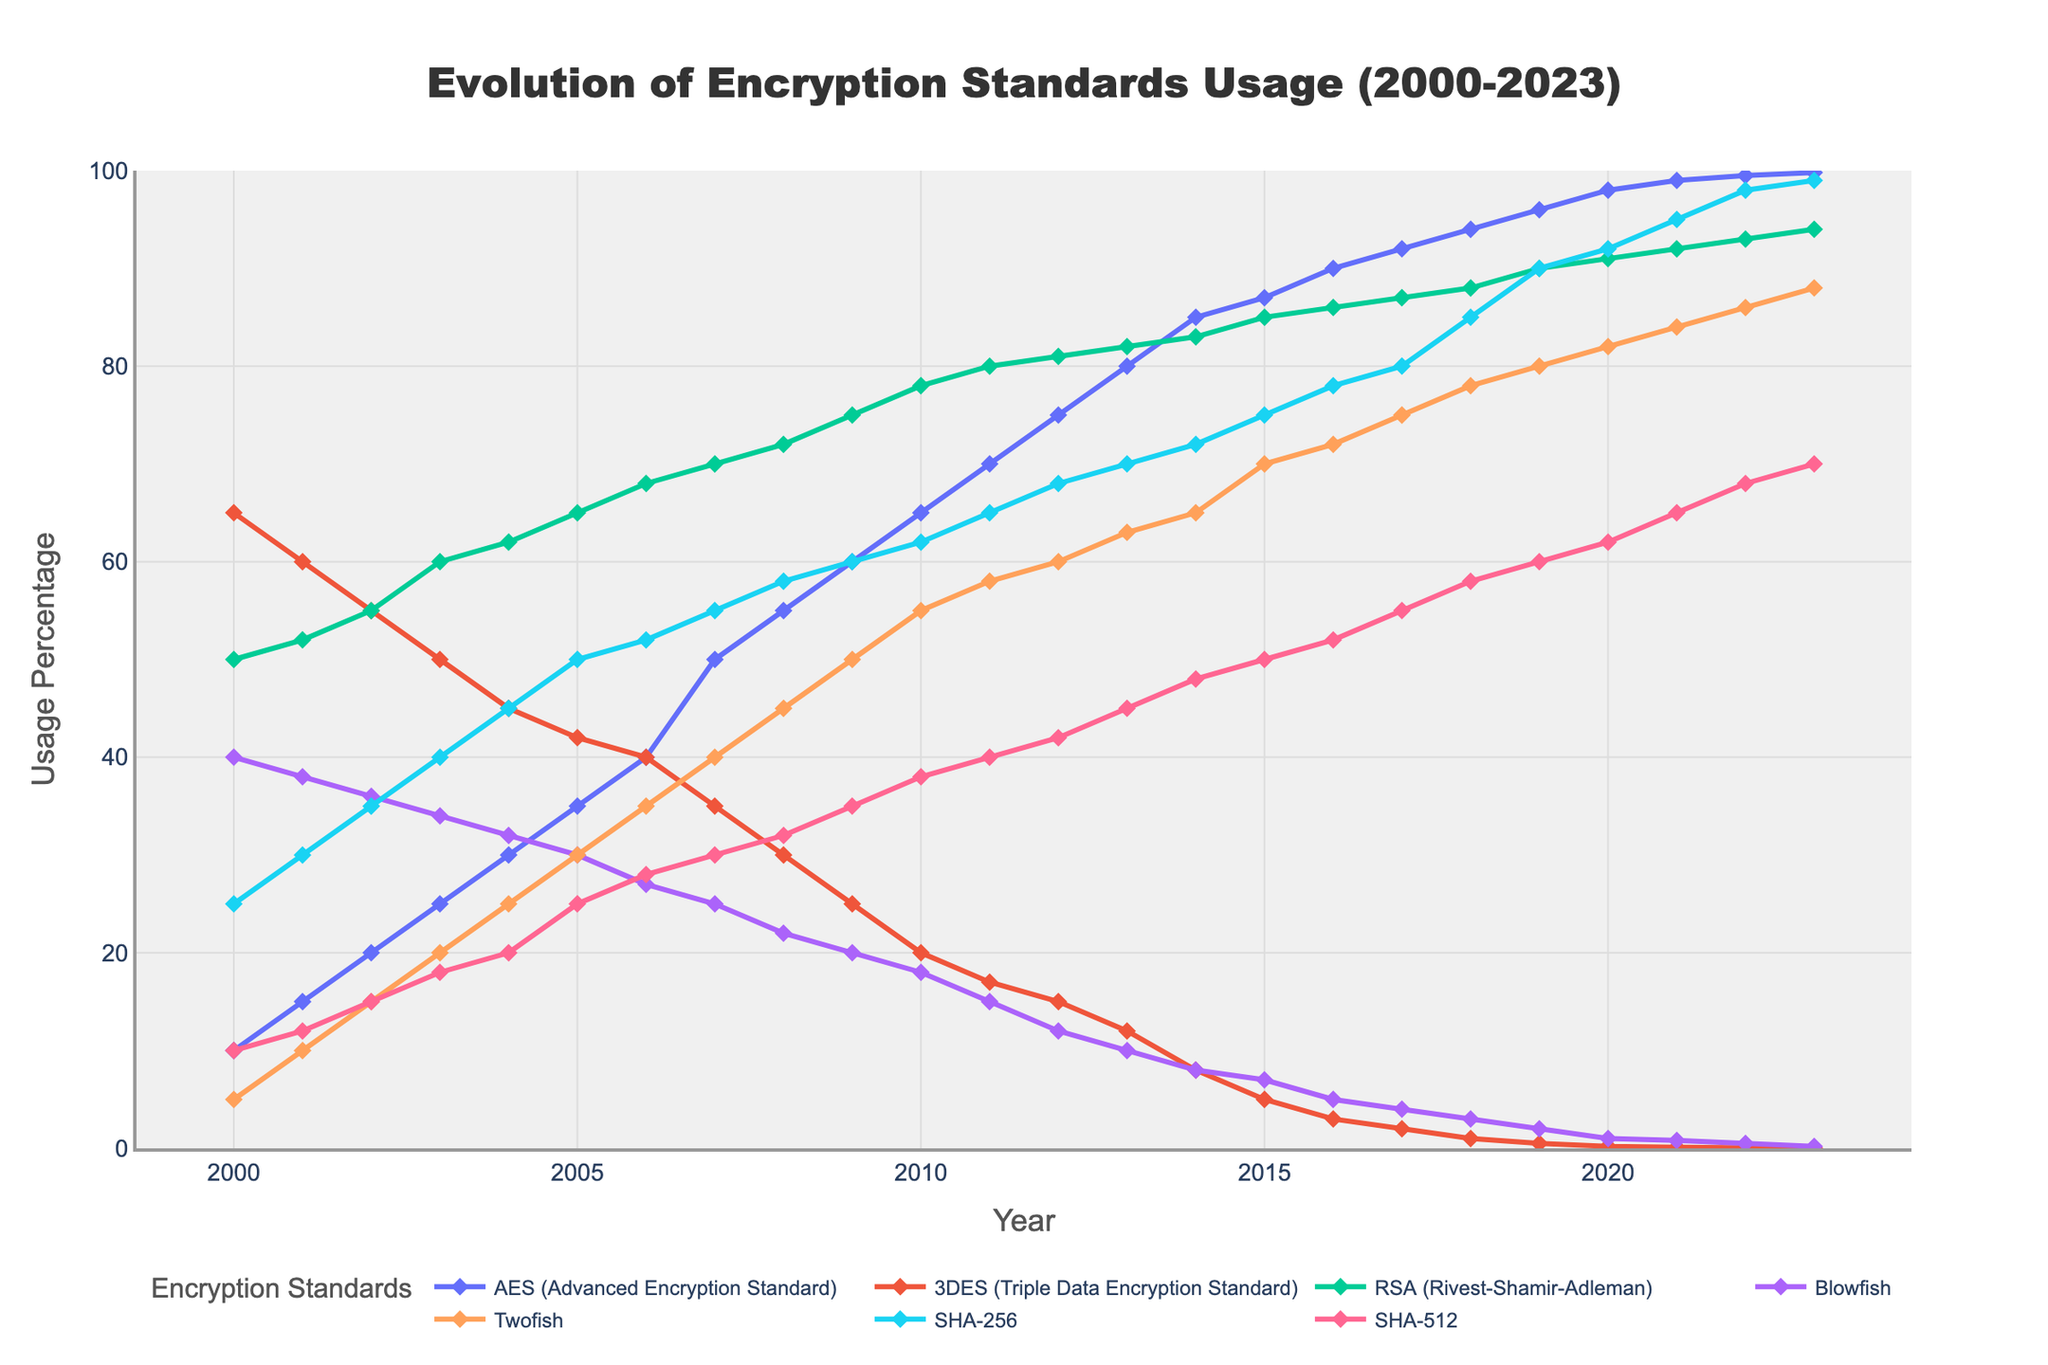What is the title of the figure? The title of the figure is located at the top and clearly indicates the subject of the plot. It reads "Evolution of Encryption Standards Usage (2000-2023)."
Answer: Evolution of Encryption Standards Usage (2000-2023) Which encryption standard had consistently decreasing usage from 2008 to 2023? To answer this, observe the lines on the plot. The line representing 3DES (Triple Data Encryption Standard) shows a consistent downward trend from 2008 to 2023.
Answer: 3DES (Triple Data Encryption Standard) In which year did AES (Advanced Encryption Standard) first surpass 50% usage? Locate the line for AES and check where it crosses the 50% usage mark on the y-axis. This occurs around the year 2007.
Answer: 2007 What was the usage percentage of RSA (Rivest-Shamir-Adleman) in the year 2010? Find the line representing RSA and trace it to the point corresponding to the year 2010. The y-value indicates the usage percentage, which is 78%.
Answer: 78% Compare the usage trends of Blowfish and Twofish from 2000 to 2023. Which had a higher initial usage and how do their trends differ? Both lines start close in 2000, but Blowfish starts higher at 40% compared to Twofish at 5%. Blowfish shows a consistent decline, while Twofish gradually increases until both lines are at a relatively low usage by 2023.
Answer: Blowfish had a higher initial usage; Blowfish declined, Twofish increased then stabilized How many encryption standards reached over 90% usage by 2023? Look at the lines and see which ones cross the 90% mark on the y-axis by 2023. Only AES and SHA-256 reach over 90% usage by 2023.
Answer: 2 encryption standards (AES and SHA-256) What is the difference in usage percentage between AES and 3DES in the year 2022? Find the usage percentages of AES and 3DES in 2022. AES is at 99.5% and 3DES is at 0.05%. Subtract the lower value from the higher to get 99.5% - 0.05% = 99.45%.
Answer: 99.45% Which encryption standard showed the most significant increase in usage from 2000 to 2023? Observe the slopes of all the lines; the steepest positive slope indicates the most significant increase. AES, with a rise from 10% to 99.8%, has the most significant increase.
Answer: AES (Advanced Encryption Standard) Between 2010 and 2015, which encryption standards saw a decrease in usage? Look at the trends between 2010 and 2015 for all lines. Both 3DES and Blowfish show a decreasing trend during this period.
Answer: 3DES and Blowfish What is the range of usage percentages for SHA-512 across the entire period? Find the minimum and maximum points of the SHA-512 line over the period from 2000 to 2023. Its usage starts at 10% in 2000 and rises to 70% by 2023, giving a range of 70% - 10% = 60%.
Answer: 60% 